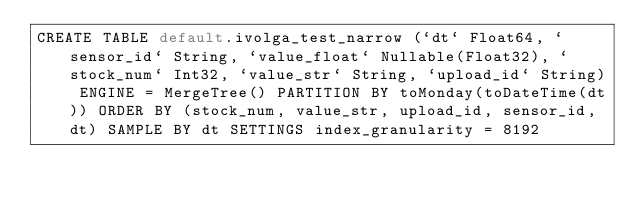<code> <loc_0><loc_0><loc_500><loc_500><_SQL_>CREATE TABLE default.ivolga_test_narrow (`dt` Float64, `sensor_id` String, `value_float` Nullable(Float32), `stock_num` Int32, `value_str` String, `upload_id` String) ENGINE = MergeTree() PARTITION BY toMonday(toDateTime(dt)) ORDER BY (stock_num, value_str, upload_id, sensor_id, dt) SAMPLE BY dt SETTINGS index_granularity = 8192
</code> 